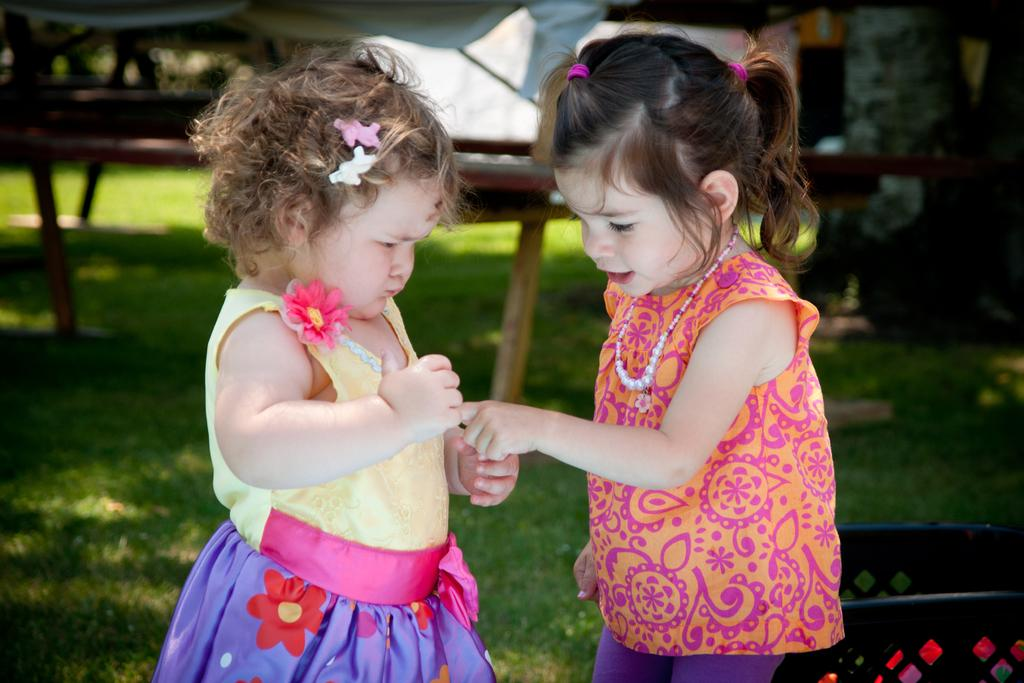How many people are in the image? There are two girls in the image. What are the girls doing in the image? The girls are standing together. What type of surface are the girls standing on? The girls are standing on grass. What can be seen in the background of the image? There are other objects visible in the background of the image. Can you see any squirrels hiding in the cave in the image? There is no cave or squirrels present in the image. 